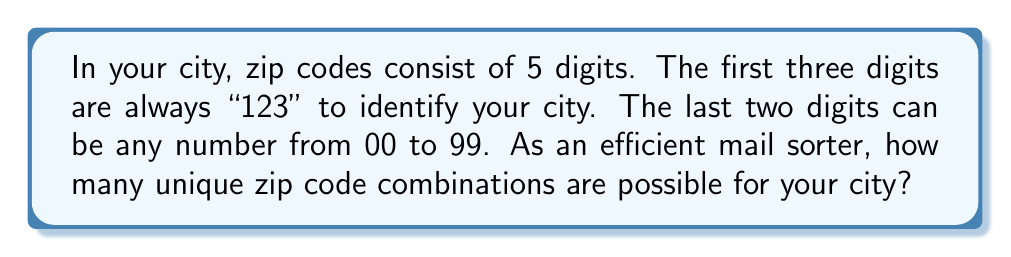Help me with this question. Let's break this down step-by-step:

1) The first three digits are fixed as "123", so we don't need to consider them in our calculation.

2) We need to focus on the last two digits, which can range from 00 to 99.

3) This is a straightforward counting problem. We need to count how many two-digit numbers exist from 00 to 99.

4) To count this systematically:
   - Single-digit numbers (00 to 09): There are 10 of these
   - Double-digit numbers (10 to 99): There are 90 of these

5) Total count: $10 + 90 = 100$

6) We can also think of this as a combination problem:
   - For the fourth digit, we have 10 choices (0 to 9)
   - For the fifth digit, we also have 10 choices (0 to 9)
   - Total combinations: $10 \times 10 = 100$

Therefore, the number of unique zip code combinations for your city is 100.
Answer: 100 